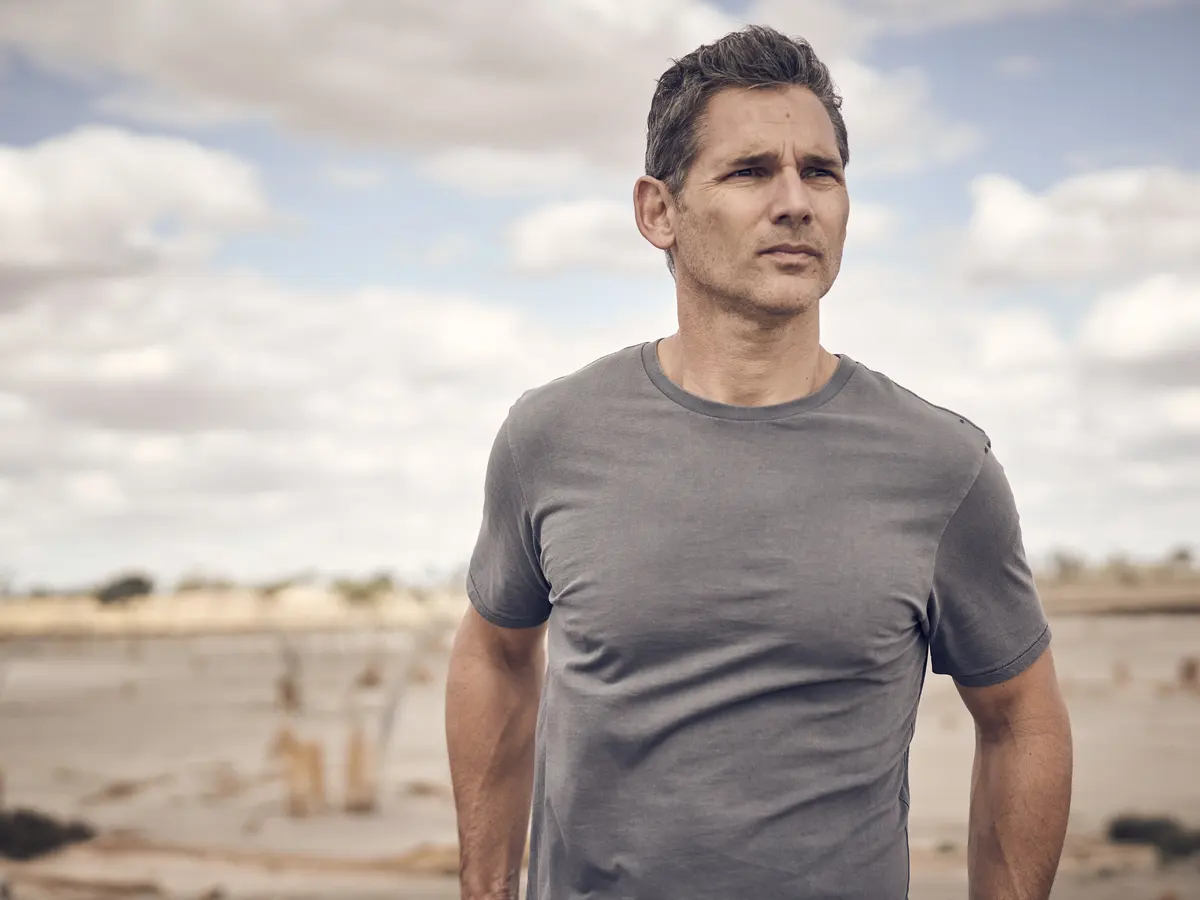What might happen right after this scene in the context of a story? Right after this scene, the man might take a deep breath and start walking along the beach, his footsteps leaving a trail in the sand as he reflects on his thoughts. He eventually comes across a message in a bottle that has washed ashore. Intrigued, he picks it up and opens it, finding a letter from a stranger who has faced similar struggles. This serendipitous discovery gives him a sense of connection and hope, propelling him forward with a newfound perspective on his own journey. 